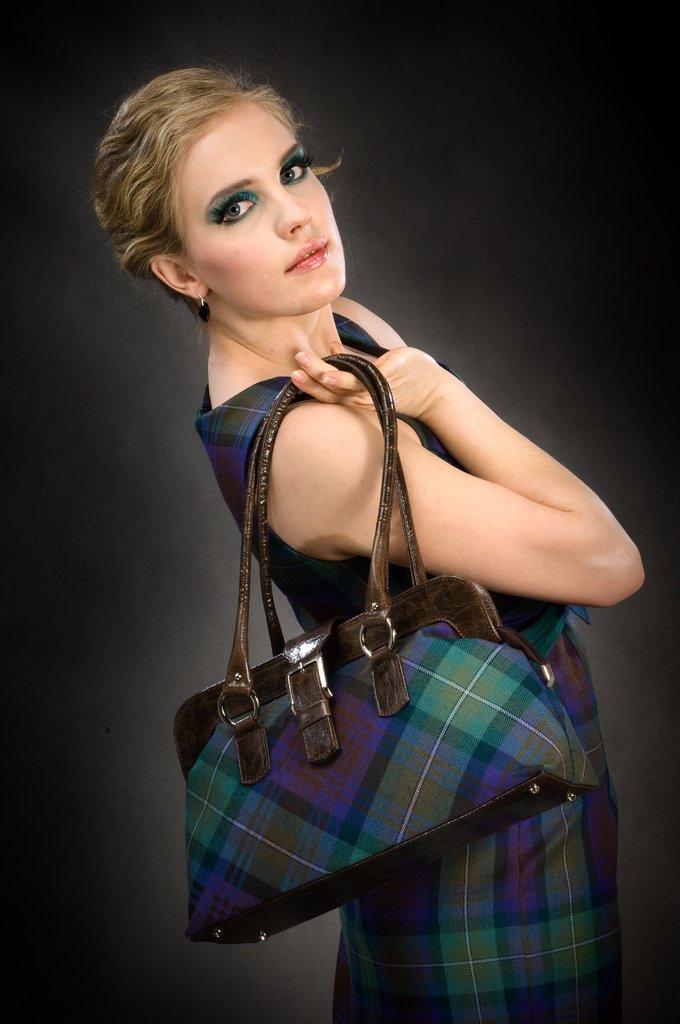In one or two sentences, can you explain what this image depicts? There is woman in the image. In which the woman is holding a handbag on her hand. 